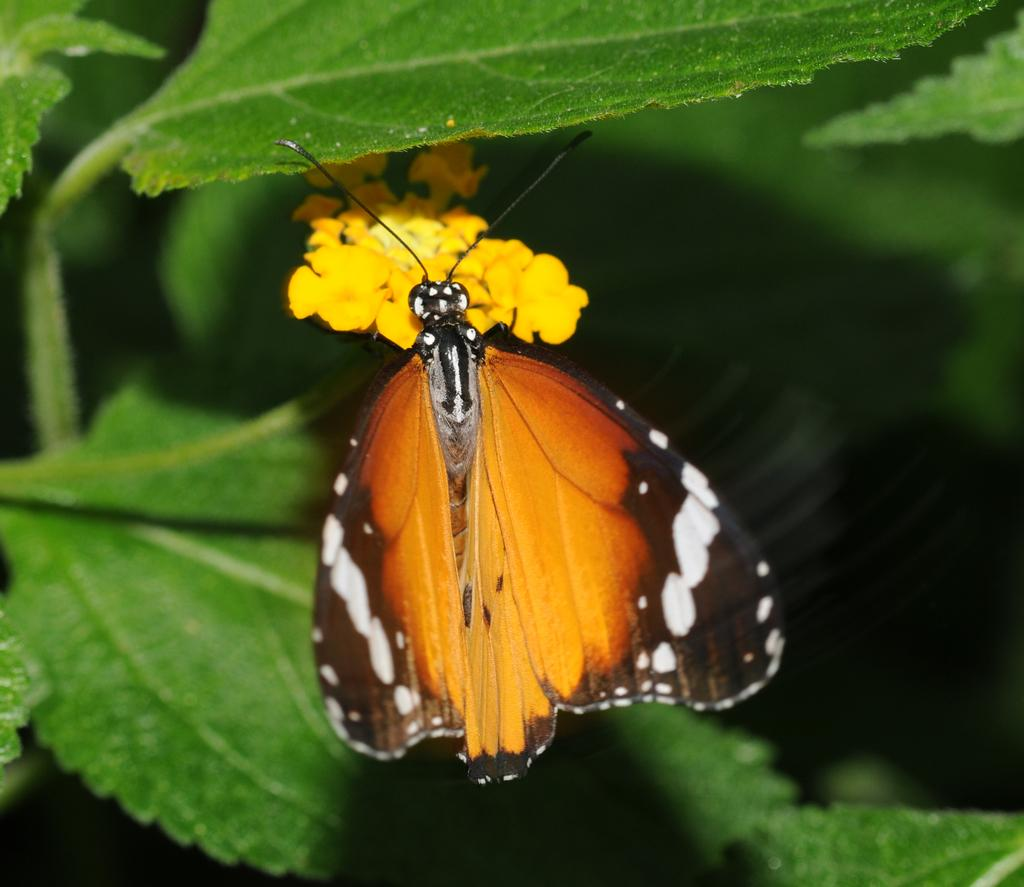What is the main subject of the picture? The main subject of the picture is a butterfly. Can you describe the butterfly in the picture? The butterfly is colorful. Where is the butterfly located in the picture? The butterfly is sitting on a yellow flower. What other elements can be seen in the picture? There are green leaves in the picture. What type of treatment is the butterfly receiving in the picture? There is no indication in the image that the butterfly is receiving any treatment. Can you tell me how the butterfly is showing its emotions in the picture? The image does not depict the butterfly's emotions, so it cannot be determined from the picture. 